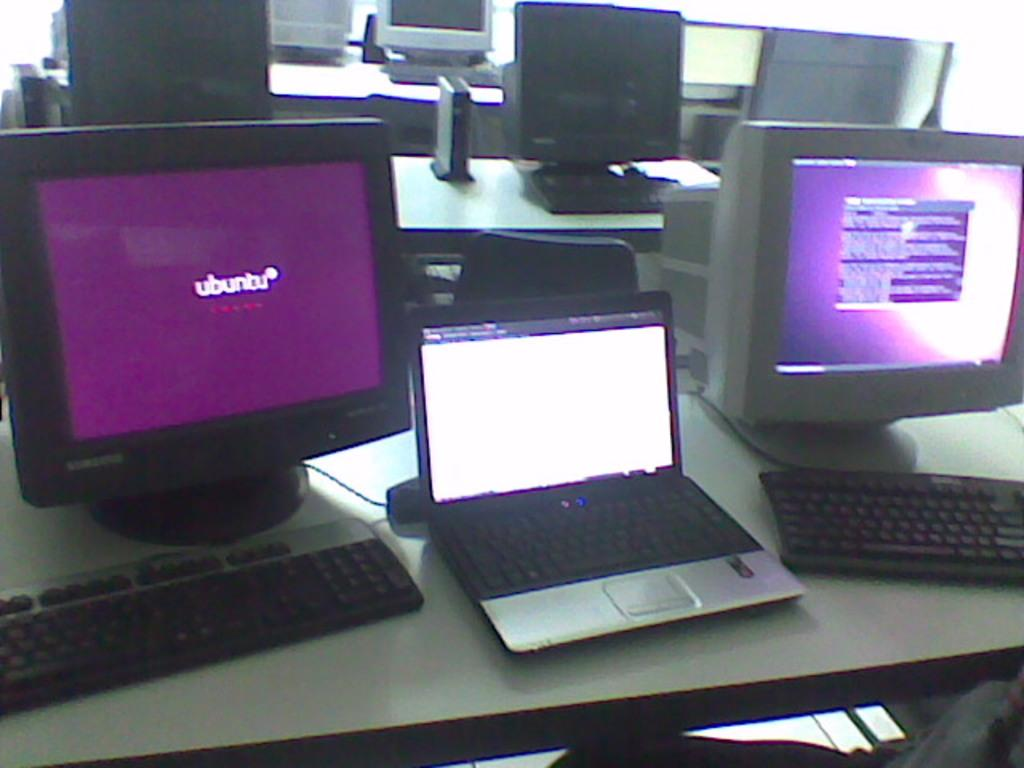Provide a one-sentence caption for the provided image. tables holding laptops, keyboards, and monitors one of which has purple ubuntu screen. 